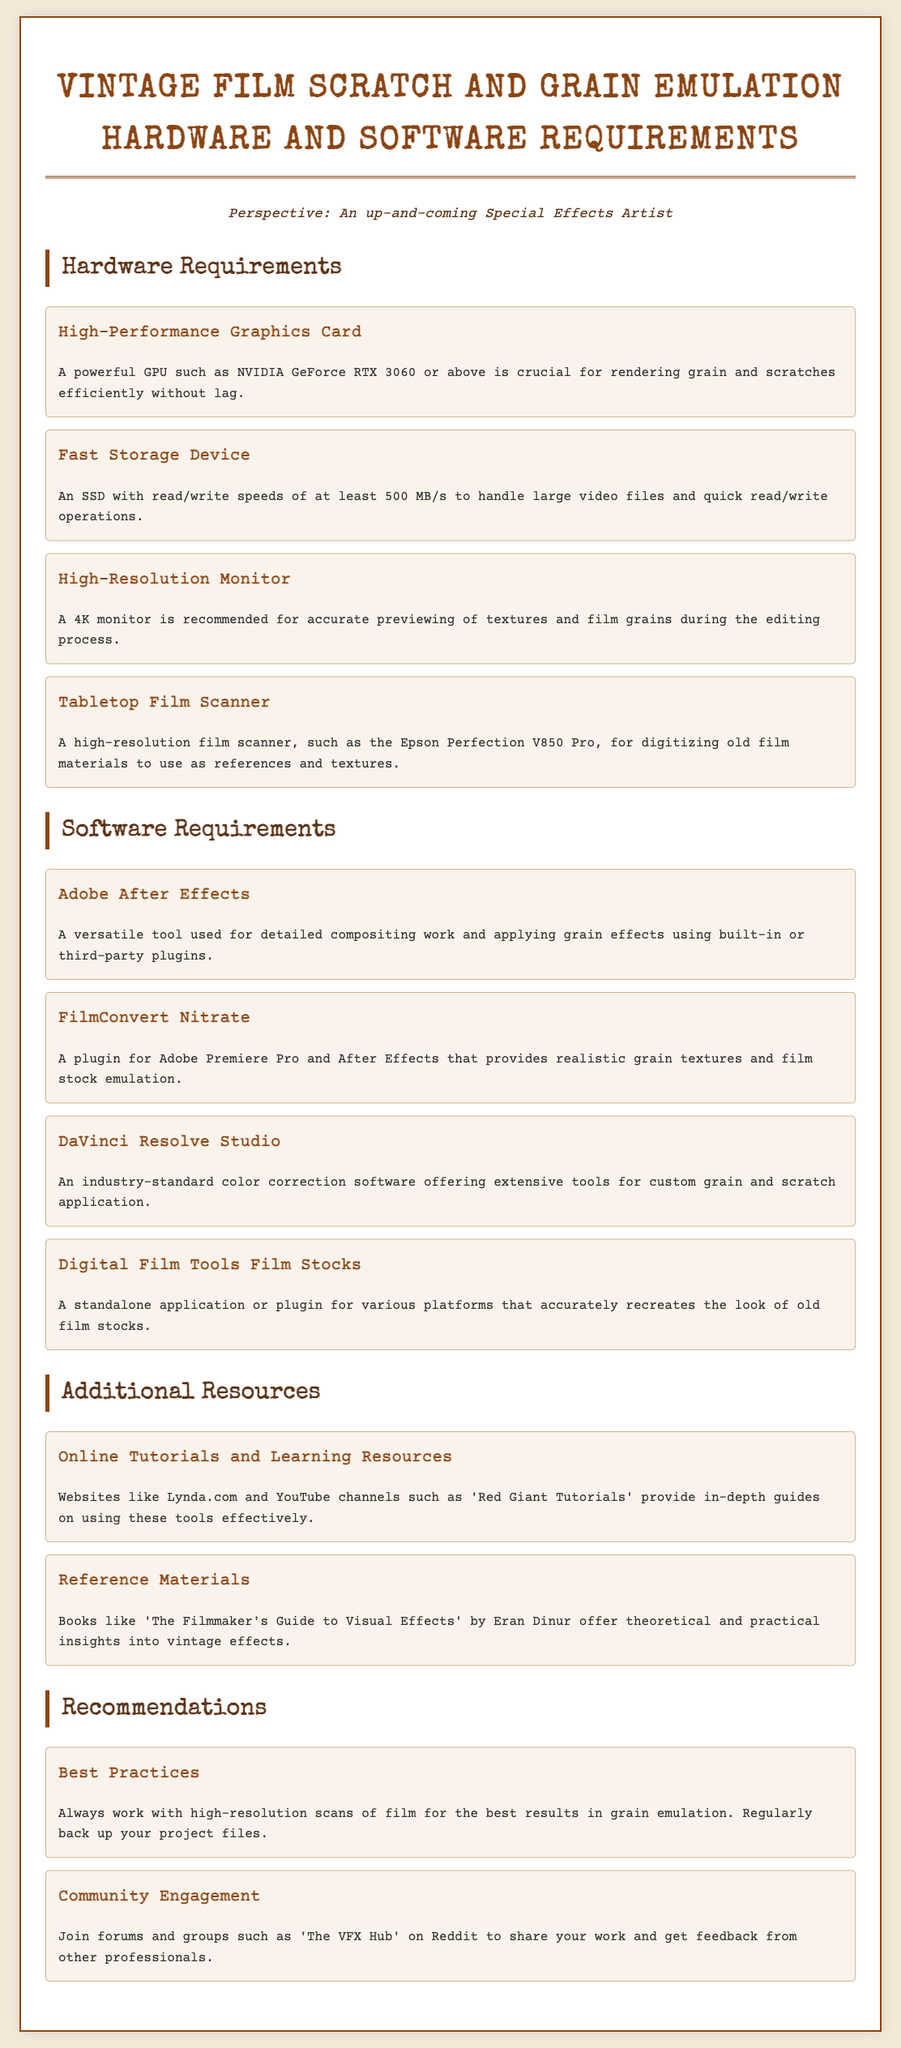What is a recommended graphics card for emulation? The document mentions "NVIDIA GeForce RTX 3060 or above" as a requirement for the hardware.
Answer: NVIDIA GeForce RTX 3060 or above What type of storage device is needed? It specifies the need for "An SSD with read/write speeds of at least 500 MB/s" to handle video files.
Answer: SSD with read/write speeds of at least 500 MB/s Which software is a versatile tool for compositing? "Adobe After Effects" is highlighted as a versatile tool for detailed compositing work.
Answer: Adobe After Effects What monitor resolution is recommended? A recommendation is made for "A 4K monitor" to accurately preview textures.
Answer: A 4K monitor What is one plugin mentioned for Adobe Premiere Pro? "FilmConvert Nitrate" is noted as a plugin that provides realistic grain textures.
Answer: FilmConvert Nitrate What should you always work with for best results? The best practice suggests "high-resolution scans of film" for optimal grain emulation.
Answer: high-resolution scans of film What is one source for online tutorials? The document references "Lynda.com" as a source for tutorials and guides.
Answer: Lynda.com How should project files be managed? A recommendation is made to "regularly back up your project files" for safety.
Answer: regularly back up your project files What community can you join for feedback? "The VFX Hub" on Reddit is mentioned as a community for sharing work and getting feedback.
Answer: The VFX Hub 